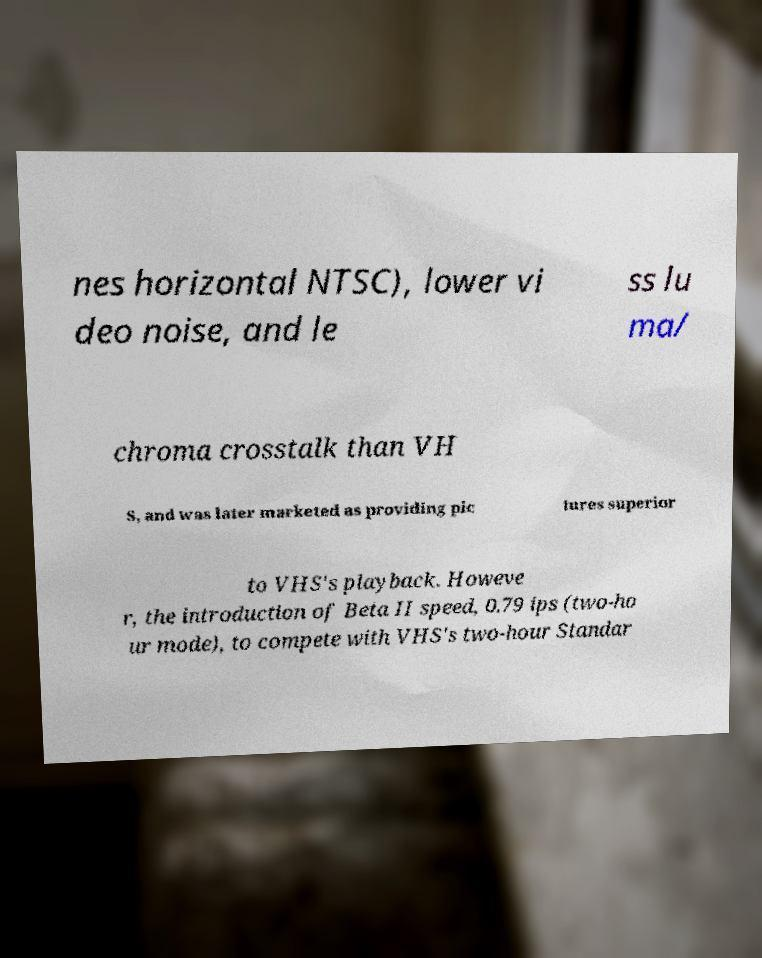Could you extract and type out the text from this image? nes horizontal NTSC), lower vi deo noise, and le ss lu ma/ chroma crosstalk than VH S, and was later marketed as providing pic tures superior to VHS's playback. Howeve r, the introduction of Beta II speed, 0.79 ips (two-ho ur mode), to compete with VHS's two-hour Standar 